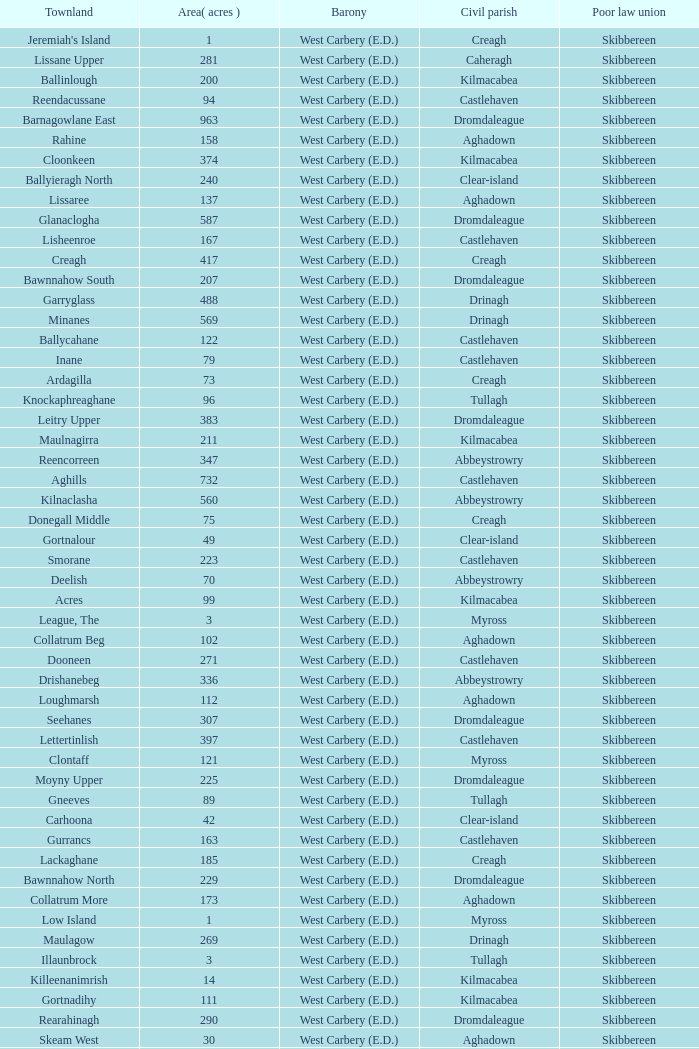What is the greatest area when the Poor Law Union is Skibbereen and the Civil Parish is Tullagh? 796.0. 